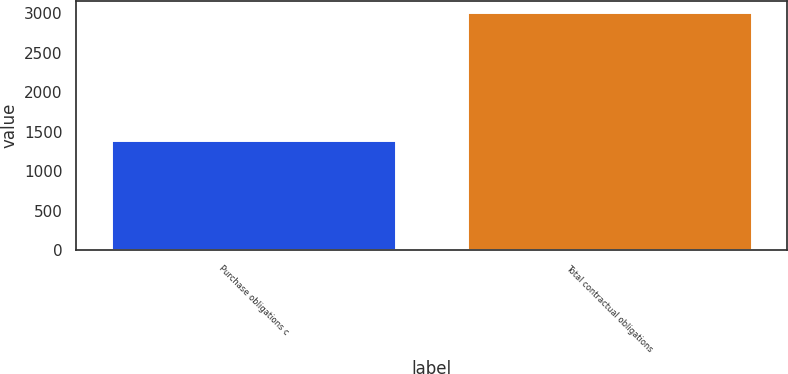Convert chart to OTSL. <chart><loc_0><loc_0><loc_500><loc_500><bar_chart><fcel>Purchase obligations c<fcel>Total contractual obligations<nl><fcel>1395<fcel>3008<nl></chart> 